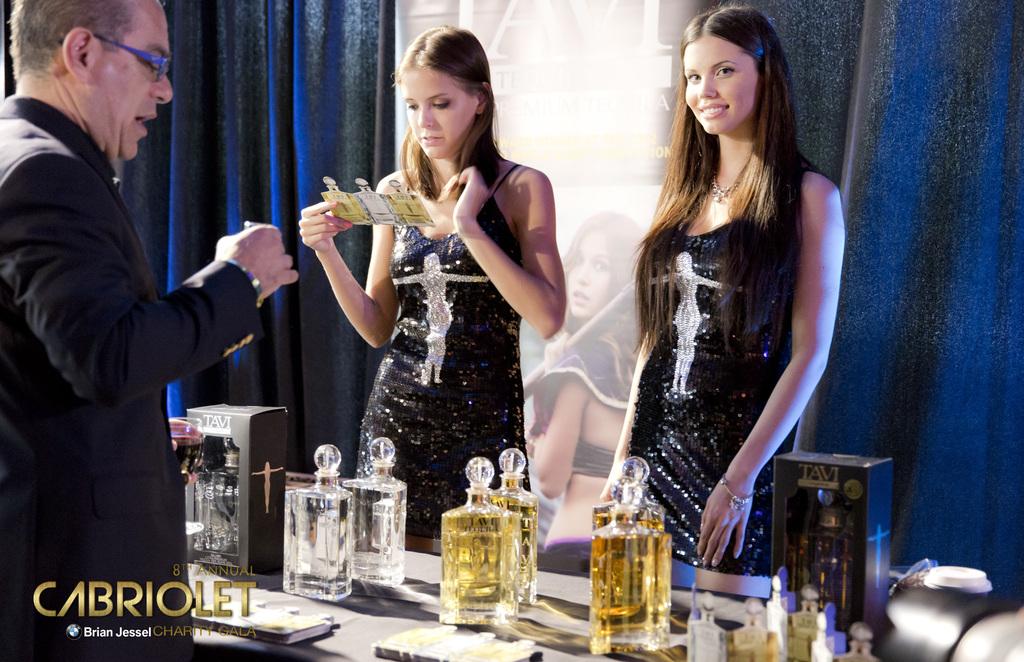What brand is being advertised?
Your answer should be compact. Cabriolet. 